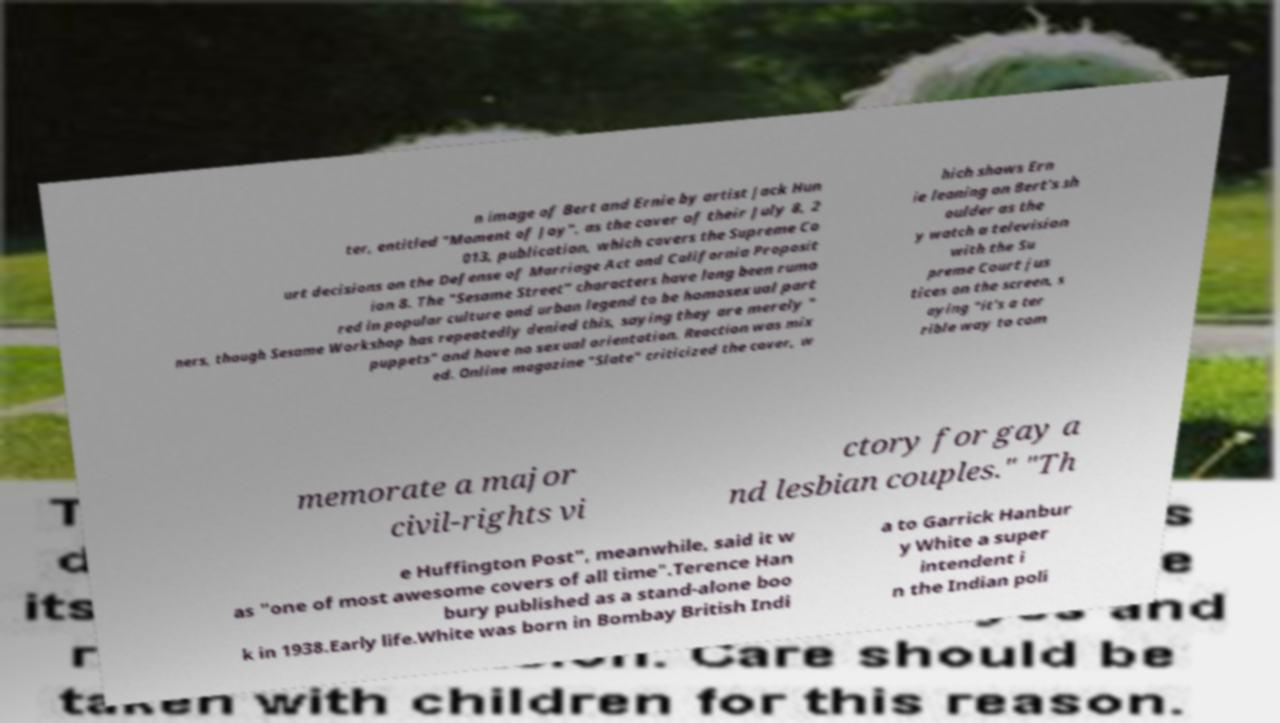For documentation purposes, I need the text within this image transcribed. Could you provide that? n image of Bert and Ernie by artist Jack Hun ter, entitled "Moment of Joy", as the cover of their July 8, 2 013, publication, which covers the Supreme Co urt decisions on the Defense of Marriage Act and California Proposit ion 8. The "Sesame Street" characters have long been rumo red in popular culture and urban legend to be homosexual part ners, though Sesame Workshop has repeatedly denied this, saying they are merely " puppets" and have no sexual orientation. Reaction was mix ed. Online magazine "Slate" criticized the cover, w hich shows Ern ie leaning on Bert's sh oulder as the y watch a television with the Su preme Court jus tices on the screen, s aying "it's a ter rible way to com memorate a major civil-rights vi ctory for gay a nd lesbian couples." "Th e Huffington Post", meanwhile, said it w as "one of most awesome covers of all time".Terence Han bury published as a stand-alone boo k in 1938.Early life.White was born in Bombay British Indi a to Garrick Hanbur y White a super intendent i n the Indian poli 